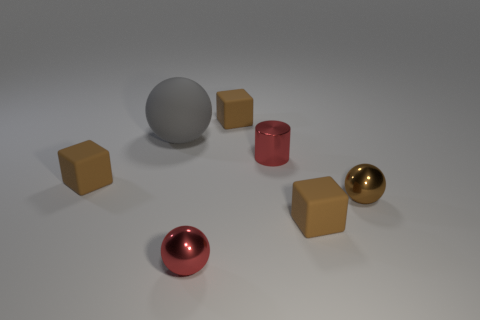The tiny metal object that is the same color as the small cylinder is what shape?
Offer a terse response. Sphere. Is there a small cylinder that is behind the small metallic thing that is behind the small brown metallic object?
Your response must be concise. No. Are there any other brown shiny objects that have the same shape as the brown metallic object?
Your answer should be very brief. No. How many small balls are behind the tiny red cylinder that is behind the cube to the left of the gray sphere?
Your answer should be compact. 0. Is the color of the cylinder the same as the small sphere on the right side of the metallic cylinder?
Your response must be concise. No. How many things are either tiny spheres in front of the large gray matte thing or small rubber objects that are in front of the small brown metal ball?
Keep it short and to the point. 3. Is the number of red cylinders that are in front of the small brown metallic sphere greater than the number of big spheres to the right of the metallic cylinder?
Offer a very short reply. No. The ball that is behind the brown metal sphere that is on the right side of the brown object left of the large ball is made of what material?
Ensure brevity in your answer.  Rubber. There is a tiny brown object behind the large rubber thing; does it have the same shape as the tiny red metallic thing in front of the brown metallic object?
Provide a succinct answer. No. Are there any blue metal cylinders that have the same size as the gray object?
Ensure brevity in your answer.  No. 